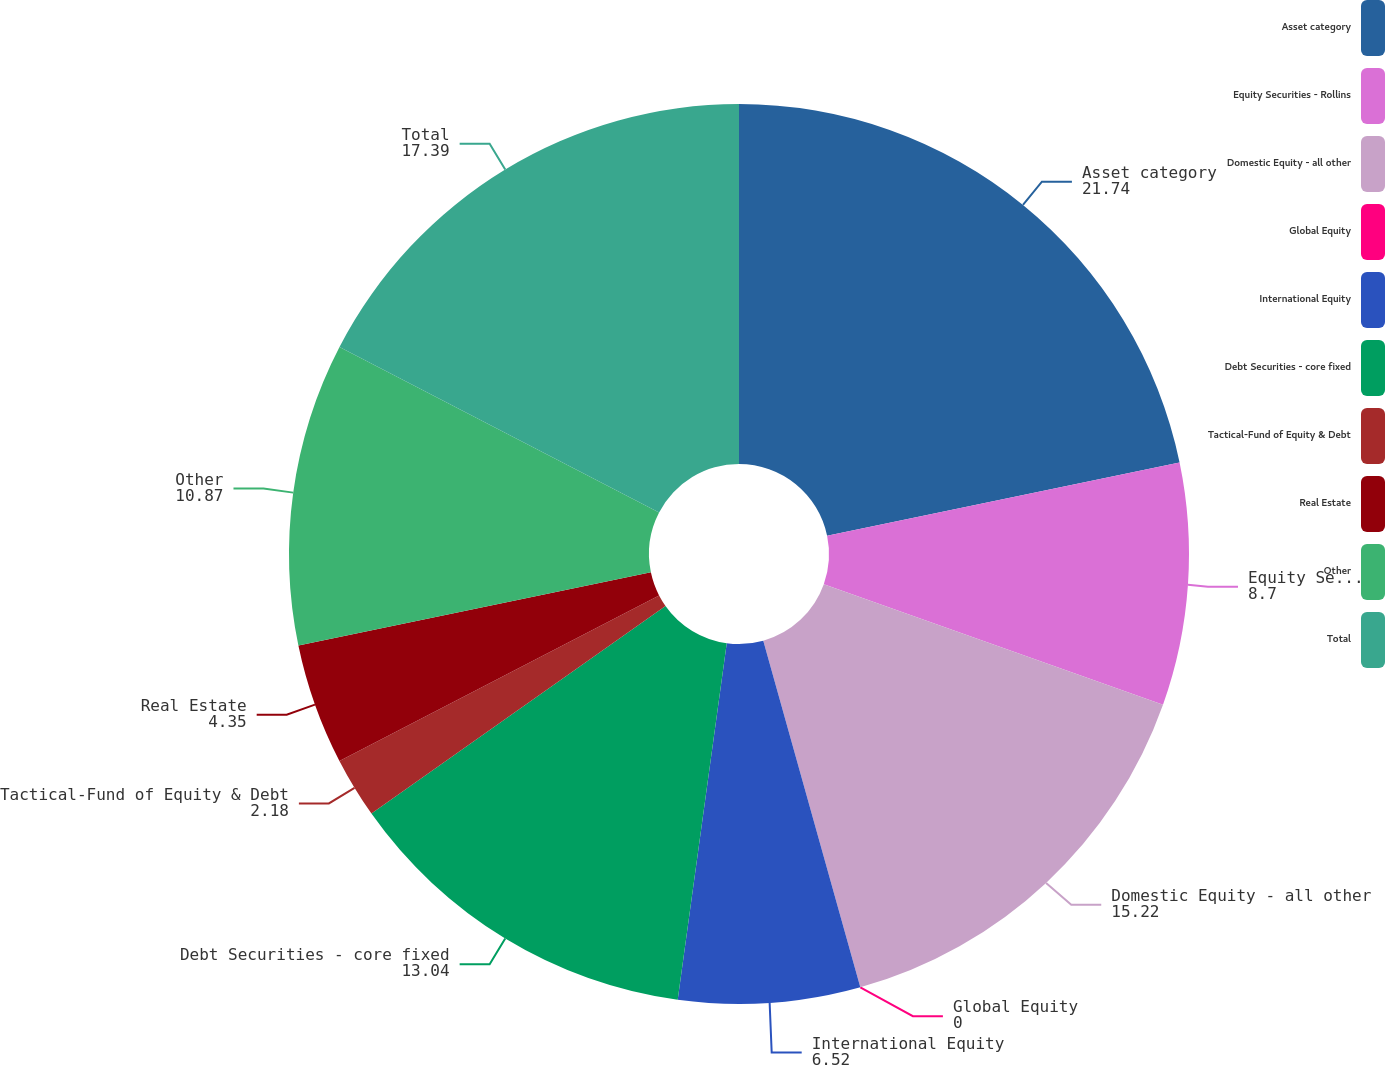Convert chart to OTSL. <chart><loc_0><loc_0><loc_500><loc_500><pie_chart><fcel>Asset category<fcel>Equity Securities - Rollins<fcel>Domestic Equity - all other<fcel>Global Equity<fcel>International Equity<fcel>Debt Securities - core fixed<fcel>Tactical-Fund of Equity & Debt<fcel>Real Estate<fcel>Other<fcel>Total<nl><fcel>21.74%<fcel>8.7%<fcel>15.22%<fcel>0.0%<fcel>6.52%<fcel>13.04%<fcel>2.18%<fcel>4.35%<fcel>10.87%<fcel>17.39%<nl></chart> 